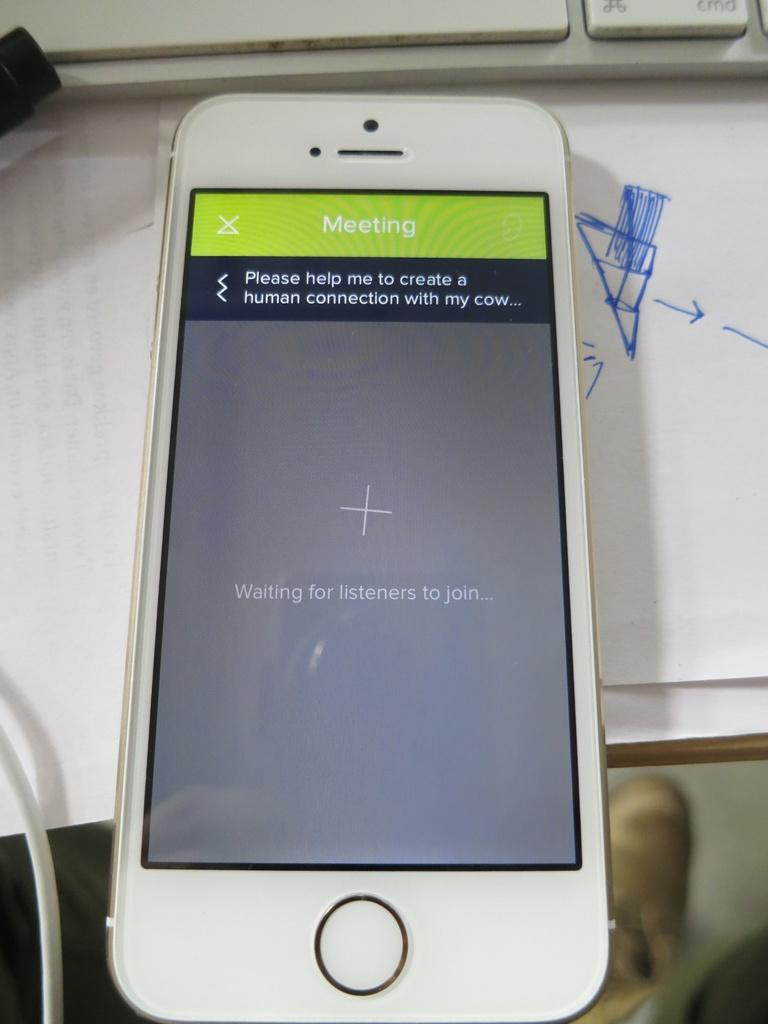<image>
Summarize the visual content of the image. A white phone that is showing a Meeting that is waiting on listeners to join. 